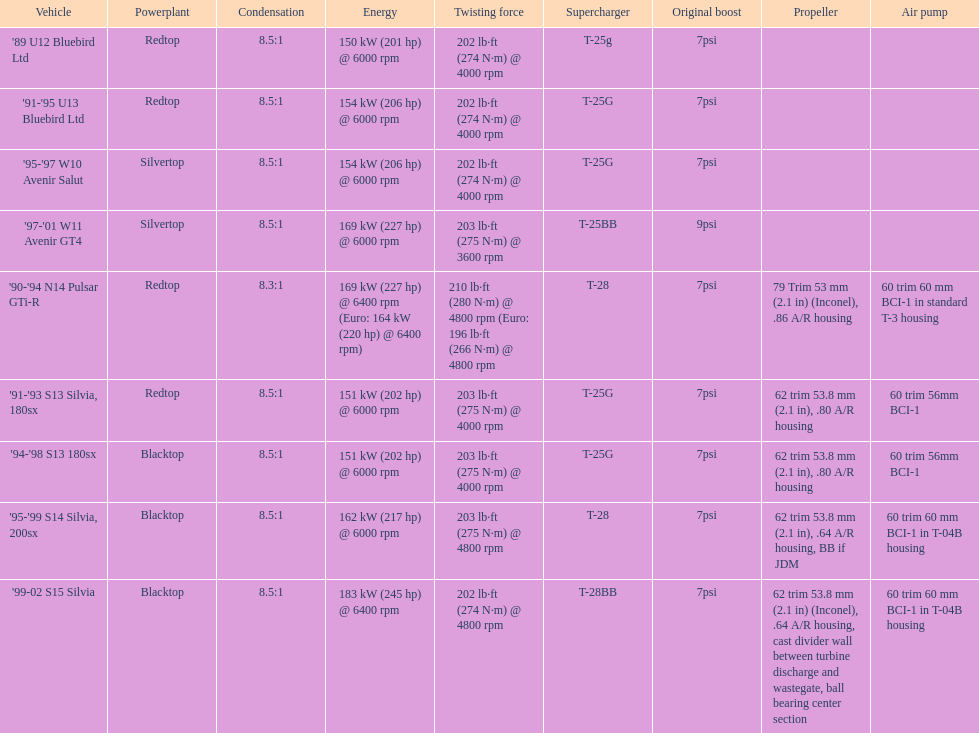Which engines were used after 1999? Silvertop, Blacktop. Give me the full table as a dictionary. {'header': ['Vehicle', 'Powerplant', 'Condensation', 'Energy', 'Twisting force', 'Supercharger', 'Original boost', 'Propeller', 'Air pump'], 'rows': [["'89 U12 Bluebird Ltd", 'Redtop', '8.5:1', '150\xa0kW (201\xa0hp) @ 6000 rpm', '202\xa0lb·ft (274\xa0N·m) @ 4000 rpm', 'T-25g', '7psi', '', ''], ["'91-'95 U13 Bluebird Ltd", 'Redtop', '8.5:1', '154\xa0kW (206\xa0hp) @ 6000 rpm', '202\xa0lb·ft (274\xa0N·m) @ 4000 rpm', 'T-25G', '7psi', '', ''], ["'95-'97 W10 Avenir Salut", 'Silvertop', '8.5:1', '154\xa0kW (206\xa0hp) @ 6000 rpm', '202\xa0lb·ft (274\xa0N·m) @ 4000 rpm', 'T-25G', '7psi', '', ''], ["'97-'01 W11 Avenir GT4", 'Silvertop', '8.5:1', '169\xa0kW (227\xa0hp) @ 6000 rpm', '203\xa0lb·ft (275\xa0N·m) @ 3600 rpm', 'T-25BB', '9psi', '', ''], ["'90-'94 N14 Pulsar GTi-R", 'Redtop', '8.3:1', '169\xa0kW (227\xa0hp) @ 6400 rpm (Euro: 164\xa0kW (220\xa0hp) @ 6400 rpm)', '210\xa0lb·ft (280\xa0N·m) @ 4800 rpm (Euro: 196\xa0lb·ft (266\xa0N·m) @ 4800 rpm', 'T-28', '7psi', '79 Trim 53\xa0mm (2.1\xa0in) (Inconel), .86 A/R housing', '60 trim 60\xa0mm BCI-1 in standard T-3 housing'], ["'91-'93 S13 Silvia, 180sx", 'Redtop', '8.5:1', '151\xa0kW (202\xa0hp) @ 6000 rpm', '203\xa0lb·ft (275\xa0N·m) @ 4000 rpm', 'T-25G', '7psi', '62 trim 53.8\xa0mm (2.1\xa0in), .80 A/R housing', '60 trim 56mm BCI-1'], ["'94-'98 S13 180sx", 'Blacktop', '8.5:1', '151\xa0kW (202\xa0hp) @ 6000 rpm', '203\xa0lb·ft (275\xa0N·m) @ 4000 rpm', 'T-25G', '7psi', '62 trim 53.8\xa0mm (2.1\xa0in), .80 A/R housing', '60 trim 56mm BCI-1'], ["'95-'99 S14 Silvia, 200sx", 'Blacktop', '8.5:1', '162\xa0kW (217\xa0hp) @ 6000 rpm', '203\xa0lb·ft (275\xa0N·m) @ 4800 rpm', 'T-28', '7psi', '62 trim 53.8\xa0mm (2.1\xa0in), .64 A/R housing, BB if JDM', '60 trim 60\xa0mm BCI-1 in T-04B housing'], ["'99-02 S15 Silvia", 'Blacktop', '8.5:1', '183\xa0kW (245\xa0hp) @ 6400 rpm', '202\xa0lb·ft (274\xa0N·m) @ 4800 rpm', 'T-28BB', '7psi', '62 trim 53.8\xa0mm (2.1\xa0in) (Inconel), .64 A/R housing, cast divider wall between turbine discharge and wastegate, ball bearing center section', '60 trim 60\xa0mm BCI-1 in T-04B housing']]} 